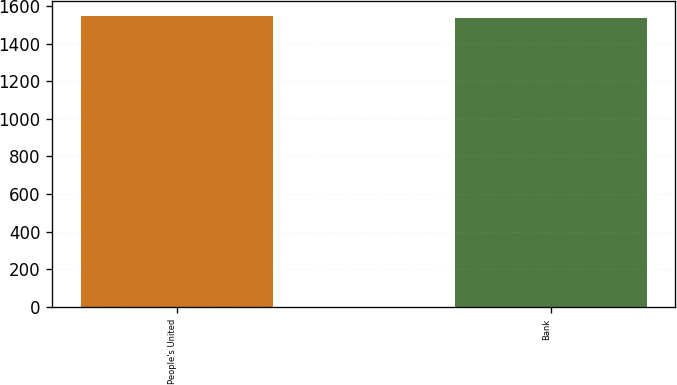Convert chart to OTSL. <chart><loc_0><loc_0><loc_500><loc_500><bar_chart><fcel>People's United<fcel>Bank<nl><fcel>1546.7<fcel>1537<nl></chart> 